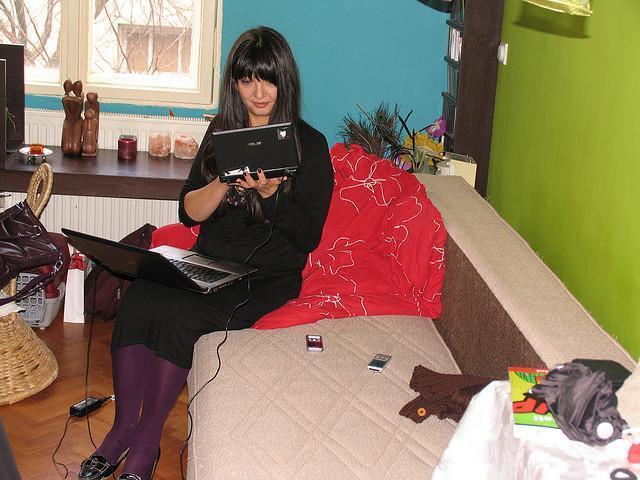Verify the accuracy of this image caption: "The person is at the edge of the couch.".
Answer yes or no. Yes. 